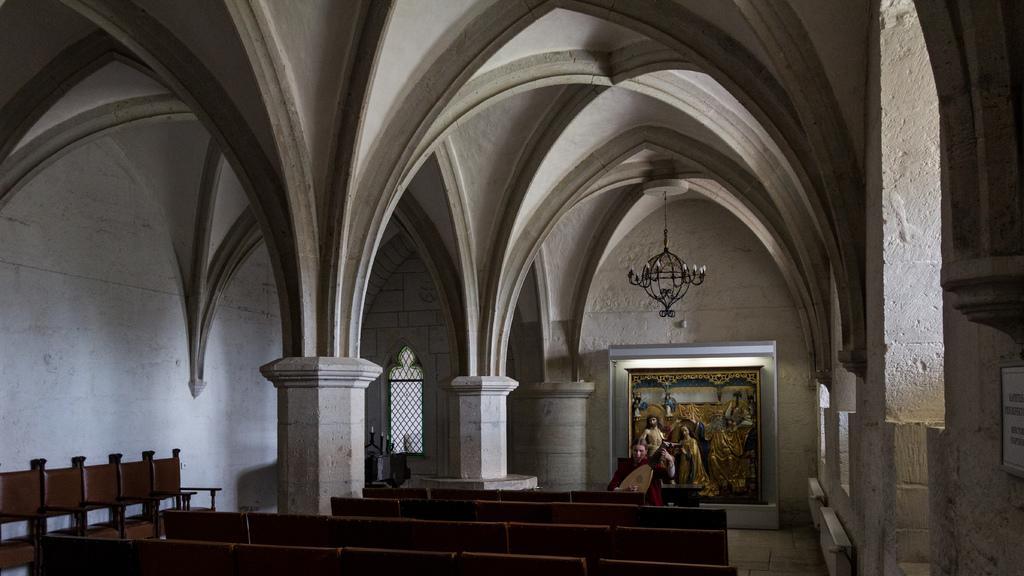Could you give a brief overview of what you see in this image? In this image I can see the inner part of the building. I can also see few pillars and windows, and the wall is in white color. Background I can see a frame attached to the wall and I can also see few benches. 